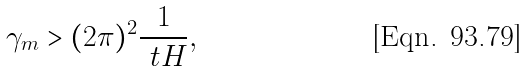<formula> <loc_0><loc_0><loc_500><loc_500>\gamma _ { m } > ( 2 \pi ) ^ { 2 } \frac { 1 } { \ t H } ,</formula> 